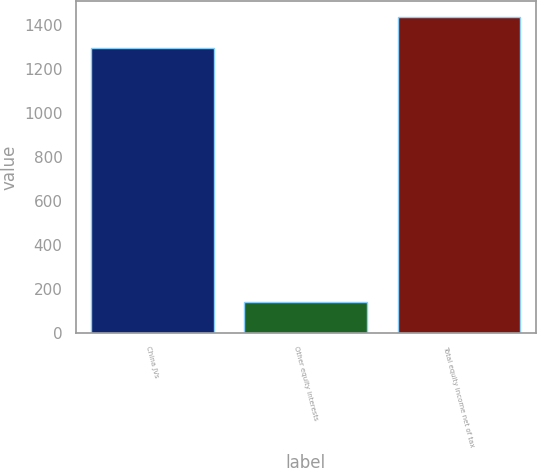Convert chart. <chart><loc_0><loc_0><loc_500><loc_500><bar_chart><fcel>China JVs<fcel>Other equity interests<fcel>Total equity income net of tax<nl><fcel>1297<fcel>141<fcel>1438<nl></chart> 